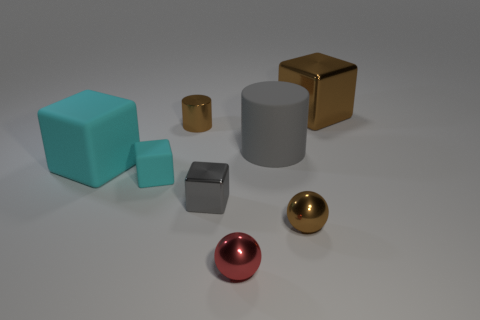What is the shape of the big object to the right of the small brown object in front of the metallic cube in front of the brown cylinder?
Keep it short and to the point. Cube. Are there the same number of big brown objects in front of the small brown cylinder and objects that are to the left of the large shiny block?
Your response must be concise. No. There is a metal cylinder that is the same size as the red shiny ball; what color is it?
Offer a very short reply. Brown. How many large things are either cyan cylinders or red metal spheres?
Provide a short and direct response. 0. There is a object that is both on the left side of the brown shiny cylinder and on the right side of the big cyan cube; what is its material?
Offer a terse response. Rubber. There is a big object that is to the left of the tiny gray block; does it have the same shape as the tiny thing that is to the right of the big matte cylinder?
Give a very brief answer. No. The matte thing that is the same color as the small metal block is what shape?
Your answer should be very brief. Cylinder. How many objects are either red things that are in front of the gray matte cylinder or tiny cyan shiny balls?
Give a very brief answer. 1. Is the size of the red metal ball the same as the brown cube?
Your response must be concise. No. What color is the shiny block on the right side of the gray shiny block?
Make the answer very short. Brown. 